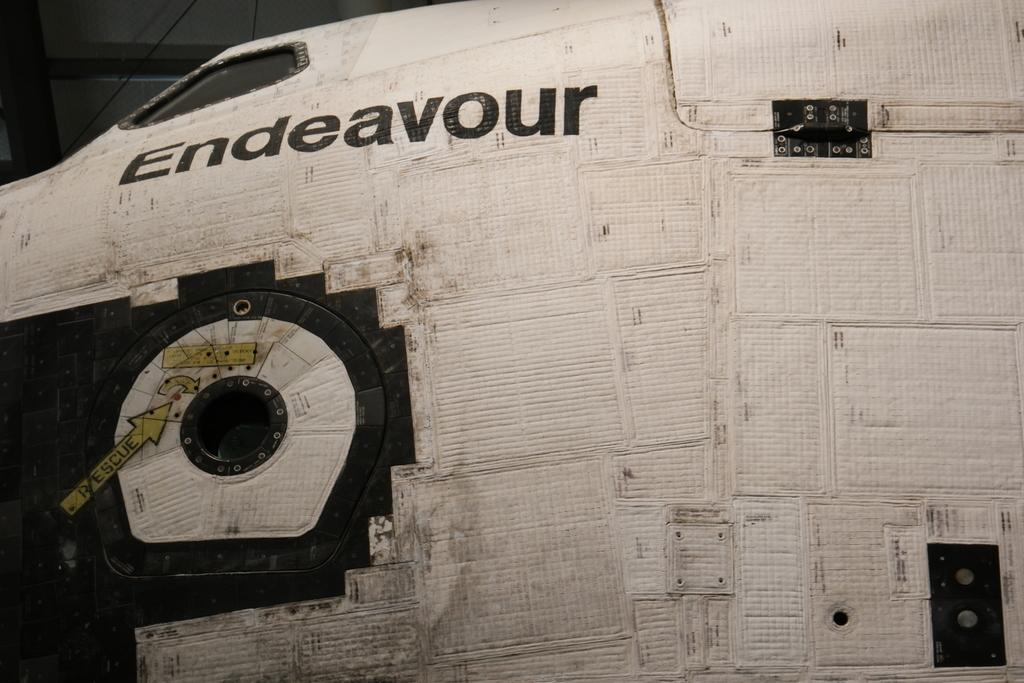What is the main subject of the image? The main subject of the image is a space shuttle. Is there any text present in the image? Yes, there is some text on the left side of the image. What can be observed about the background of the image? The background of the image is dark. What type of coal is being used to bake the bread in the image? There is no coal or bread present in the image; it features a space shuttle and some text. 